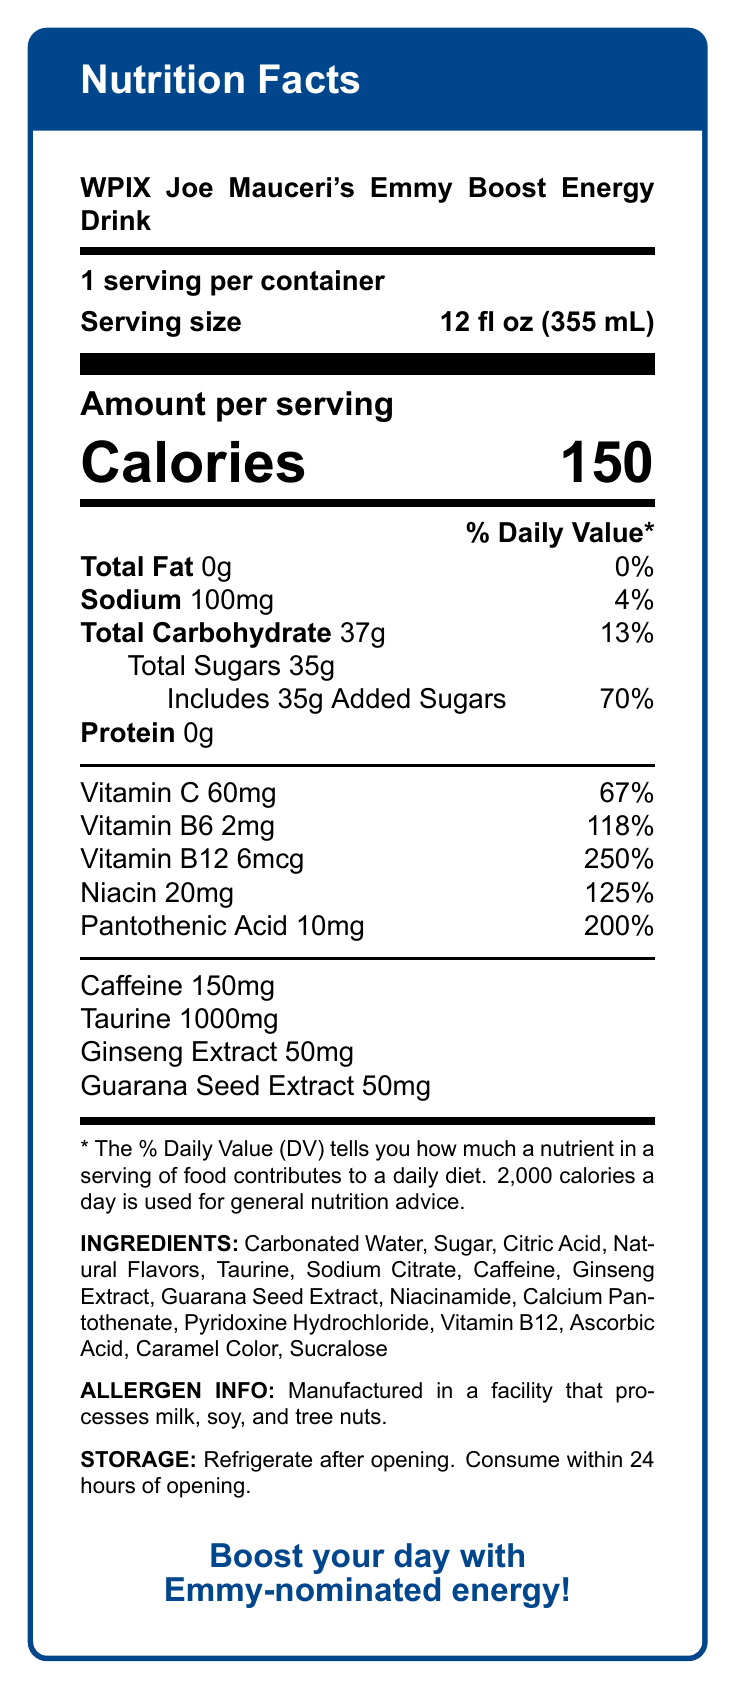what is the serving size? The serving size is listed in the document as 12 fl oz (355 mL).
Answer: 12 fl oz (355 mL) how many servings are there per container? The document mentions there is 1 serving per container.
Answer: 1 how many calories are in one serving? The calories amount per serving is directly specified as 150.
Answer: 150 calories how much total fat does this drink contain? According to the document, Total Fat is listed as 0g.
Answer: 0g how much caffeine is in the drink? The amount of caffeine is stated to be 150mg in the document.
Answer: 150mg how much Vitamin C is in one serving of the drink? The document specifies that one serving contains 60mg of Vitamin C.
Answer: 60mg What's the % Daily Value of added sugars in this drink? The % Daily Value for added sugars is shown as 70%.
Answer: 70% what precaution should be taken once the energy drink is opened? The document states that the drink should be refrigerated after opening and consumed within 24 hours.
Answer: Refrigerate after opening. Consume within 24 hours of opening. A. Guarana Seed Extract
B. Vitamin B12
C. Aspartame The ingredients listed include Guarana Seed Extract and Vitamin B12, but not Aspartame.
Answer: C. Aspartame 1. Vitamin C
2. Vitamin B6
3. Vitamin B12 Vitamin B12 has the highest % Daily Value at 250%.
Answer: 3. Vitamin B12 does this drink contain any protein? The document specifies that Protein is 0g, so the drink contains no protein.
Answer: No is there a QR code on this product's label? The document mentions a QR code linking to Joe Mauceri's WPIX bio as one of the special features.
Answer: Yes summarize the main features of this energy drink's nutrition label. This summary describes the main nutritional components, vitamins, and special features of the WPIX Joe Mauceri's Emmy Boost Energy Drink.
Answer: WPIX Joe Mauceri's Emmy Boost Energy Drink contains 150 calories per 12 fl oz (355 mL) serving, with no fat or protein, 100mg of sodium (4% DV), 37g of carbohydrates (13% DV) including 35g of sugars making up 70% DV of added sugars. It is rich in several vitamins: Vitamin C (67% DV), Vitamin B6 (118% DV), Vitamin B12 (250% DV), Niacin (125% DV), and Pantothenic Acid (200% DV). It contains 150mg of caffeine along with Taurine (1000mg), Ginseng Extract (50mg), and Guarana Seed Extract (50mg). The ingredients include carbonated water, sugar, citric acid, and other additives. Special features include a QR code and an Emmy trophy holographic sticker. how much sodium is in the drink? The document clearly states that the amount of sodium is 100mg per serving.
Answer: 100mg does this drink contain any allergens? The allergen information notes that the drink is manufactured in a facility that processes milk, soy, and tree nuts.
Answer: Yes what is the marketing slogan of this energy drink? The marketing slogan is "Boost your day with Emmy-nominated energy!" as mentioned in the document.
Answer: Boost your day with Emmy-nominated energy! what's the total amount of carbohydrates in the drink? The document states that the total carbohydrate content is 37g per serving.
Answer: 37g where is Joe Mauceri's image located on the can? The document mentions that Joe Mauceri's image is a smiling headshot on the front of the can.
Answer: Smiling headshot on the front of the can does the drink need to be refrigerated before opening? The document only specifies refrigeration after opening, not before.
Answer: Not enough information 